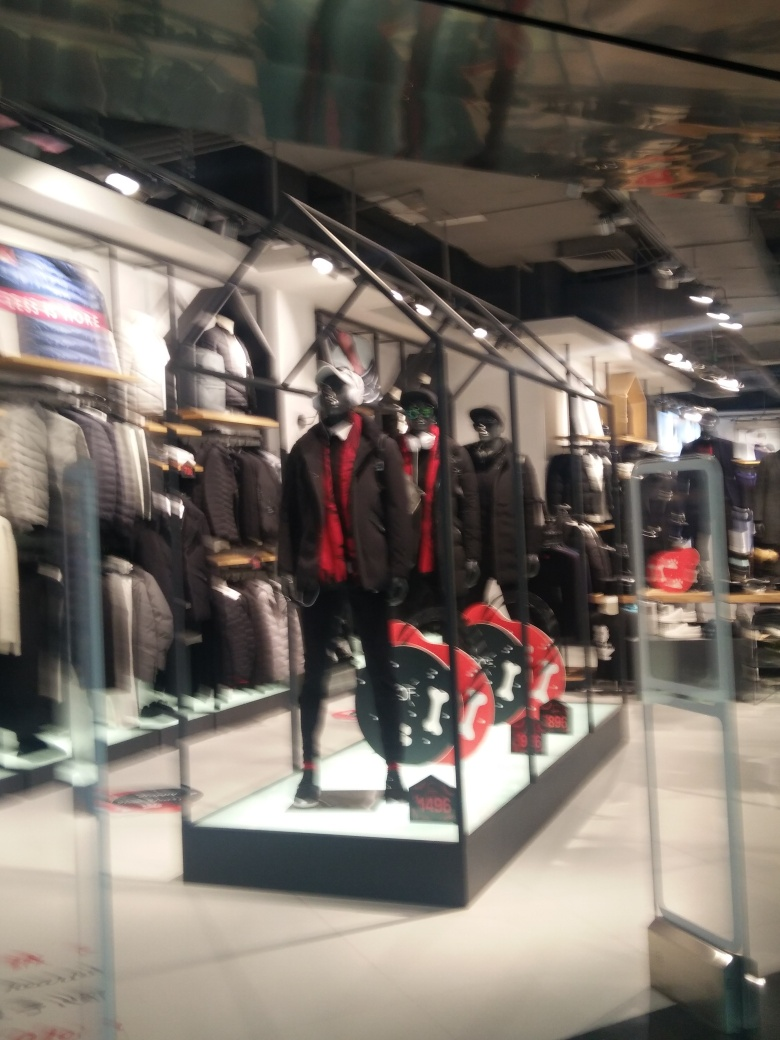What parts of the image are blurry? In the image, the blurry parts are primarily located around the edges and background. This blur highlights the central display of mannequins, drawing the viewer's focus to the sharp details of their attire and the products being featured. 